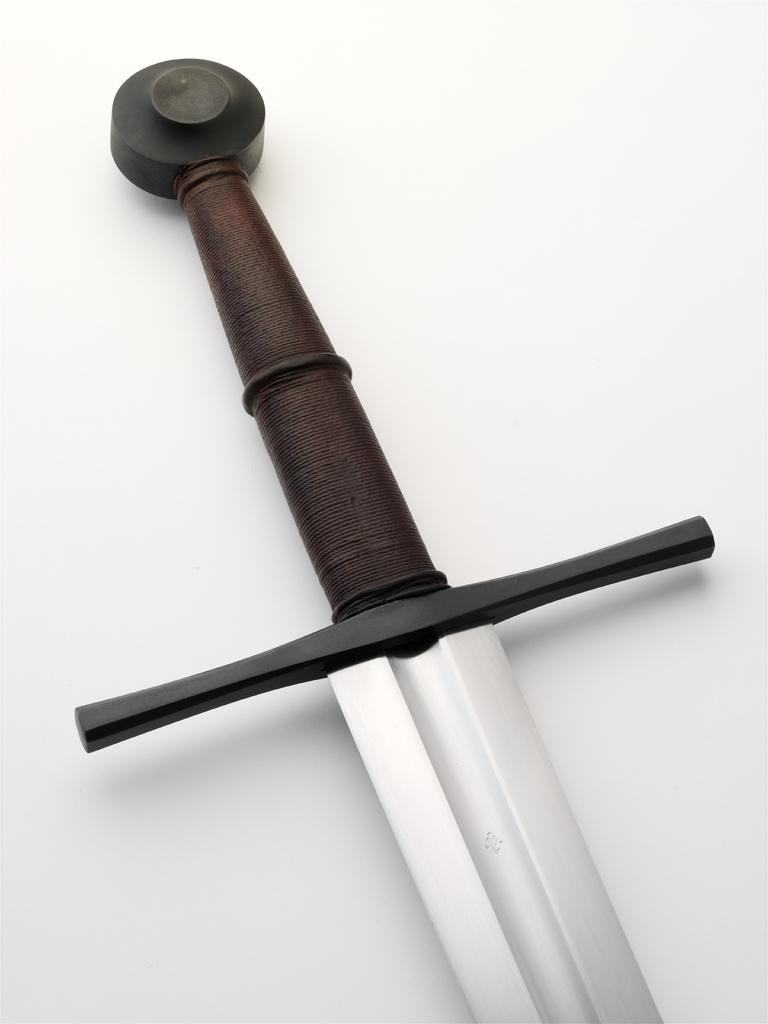What object can be seen in the image? There is a dagger in the image. How many bees are buzzing around the dagger in the image? There are no bees present in the image; it only features a dagger. What type of cast is visible on the dagger in the image? There is no cast present on the dagger in the image. 